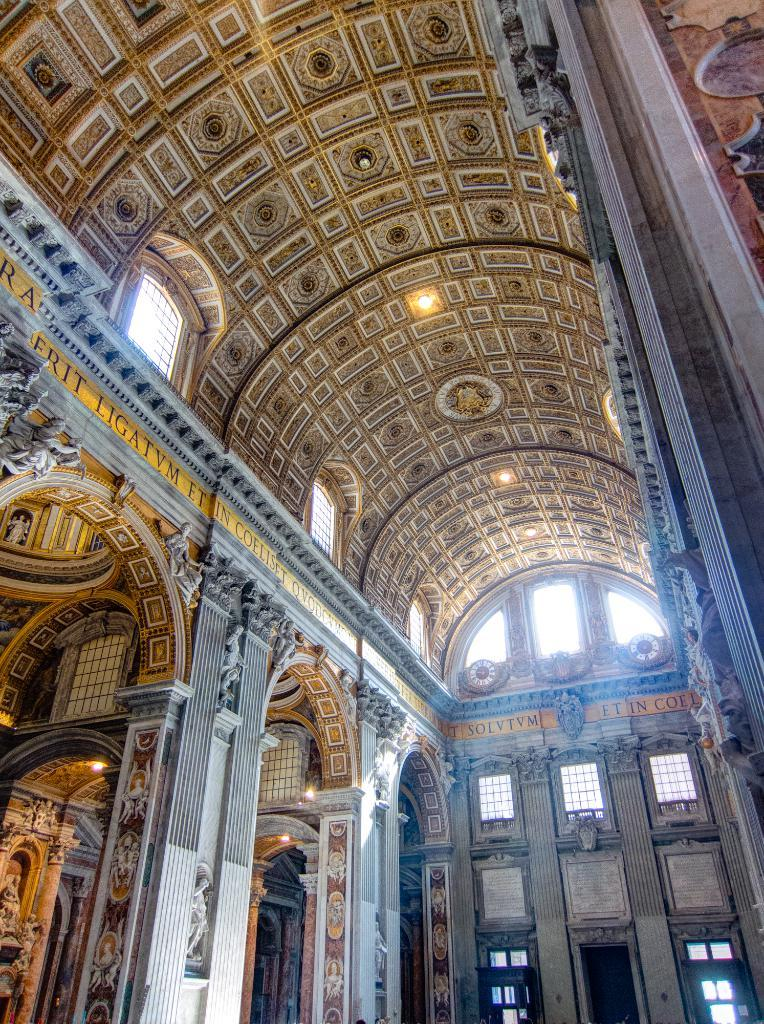What type of location is depicted in the image? The image is of the inside of a building. What architectural feature can be seen in the image? There are glass windows in the image. What can be used to provide illumination in the image? There are lights visible in the image. What is the shape of the ceiling in the image? There is a dome at the top of the image. What type of screw can be seen holding the dome in place in the image? There are no screws visible in the image; the dome appears to be supported by the structure of the building. 